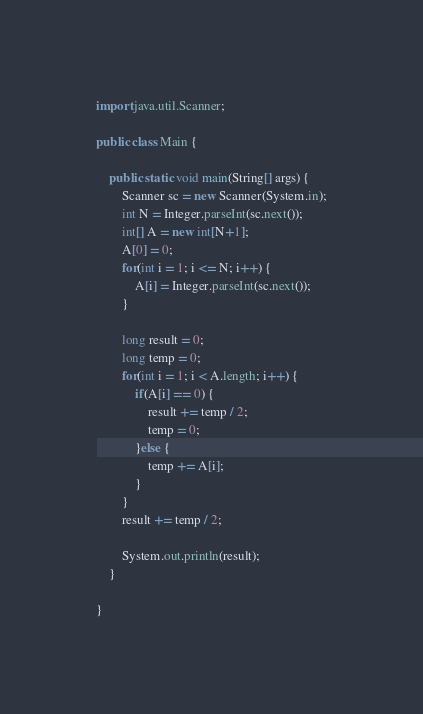<code> <loc_0><loc_0><loc_500><loc_500><_Java_>import java.util.Scanner;

public class Main {

	public static void main(String[] args) {
		Scanner sc = new Scanner(System.in);
		int N = Integer.parseInt(sc.next());
		int[] A = new int[N+1];
		A[0] = 0;
		for(int i = 1; i <= N; i++) {
			A[i] = Integer.parseInt(sc.next());
		}

		long result = 0;
		long temp = 0;
		for(int i = 1; i < A.length; i++) {
			if(A[i] == 0) {
				result += temp / 2;
				temp = 0;
			}else {
				temp += A[i];
			}
		}
		result += temp / 2;

		System.out.println(result);
	}

}
</code> 